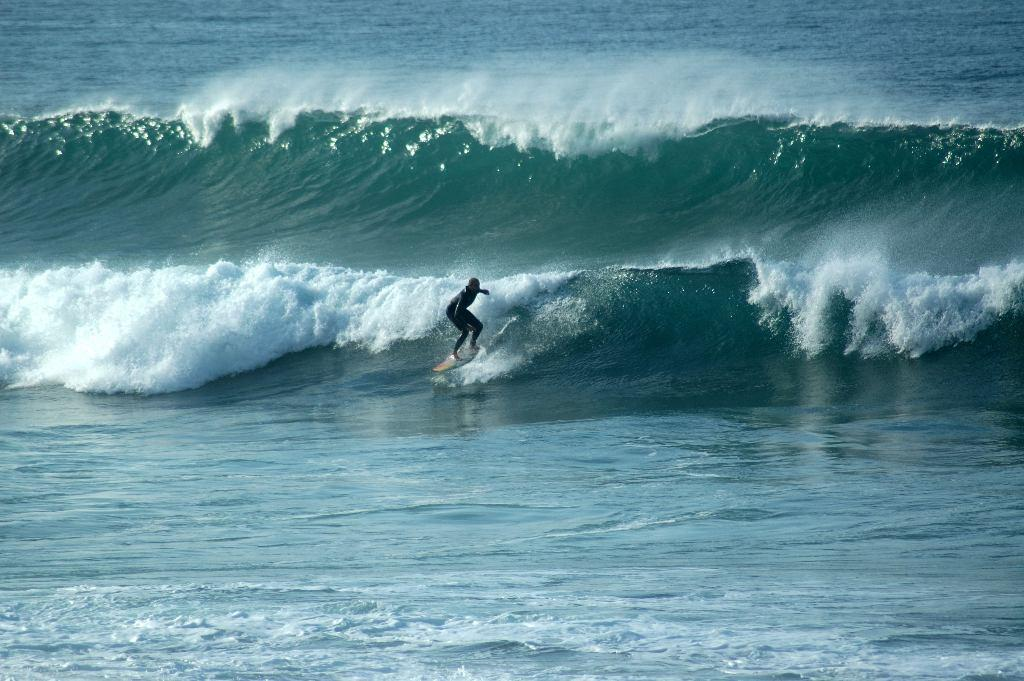What is the main subject of the image? There is a person in the image. What activity is the person engaged in? The person is surfing on the sea. What type of flock can be seen flying in the background of the image? There is no flock visible in the image, as the person is surfing on the sea. 